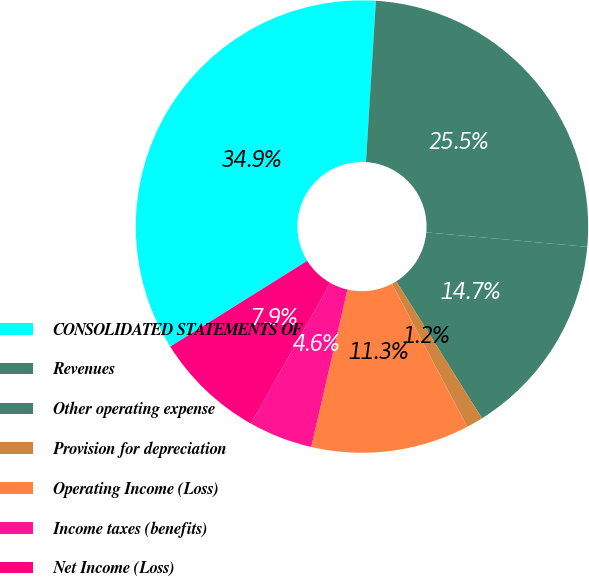Convert chart. <chart><loc_0><loc_0><loc_500><loc_500><pie_chart><fcel>CONSOLIDATED STATEMENTS OF<fcel>Revenues<fcel>Other operating expense<fcel>Provision for depreciation<fcel>Operating Income (Loss)<fcel>Income taxes (benefits)<fcel>Net Income (Loss)<nl><fcel>34.88%<fcel>25.45%<fcel>14.67%<fcel>1.2%<fcel>11.3%<fcel>4.57%<fcel>7.93%<nl></chart> 